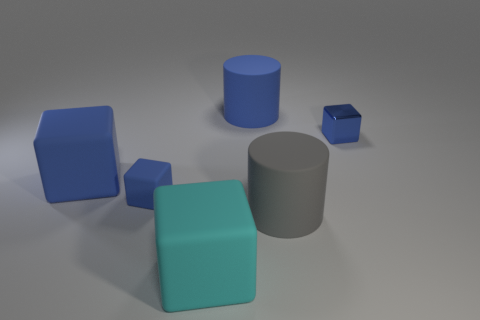Are there more cylinders behind the large cyan object than rubber cylinders that are in front of the big gray matte object?
Your response must be concise. Yes. Are there any other big rubber things of the same shape as the gray thing?
Your answer should be compact. Yes. The cyan thing that is the same size as the blue rubber cylinder is what shape?
Your response must be concise. Cube. What shape is the tiny blue thing on the right side of the cyan block?
Offer a very short reply. Cube. Is the number of large rubber cubes behind the small metal object less than the number of cyan things behind the tiny blue rubber block?
Provide a succinct answer. No. There is a metal cube; does it have the same size as the blue rubber block that is in front of the big blue cube?
Provide a short and direct response. Yes. How many rubber cylinders are the same size as the cyan cube?
Your response must be concise. 2. What color is the tiny thing that is made of the same material as the big blue cylinder?
Provide a succinct answer. Blue. Are there more blue cubes than big cubes?
Your response must be concise. Yes. Are the large gray object and the large blue cylinder made of the same material?
Your response must be concise. Yes. 